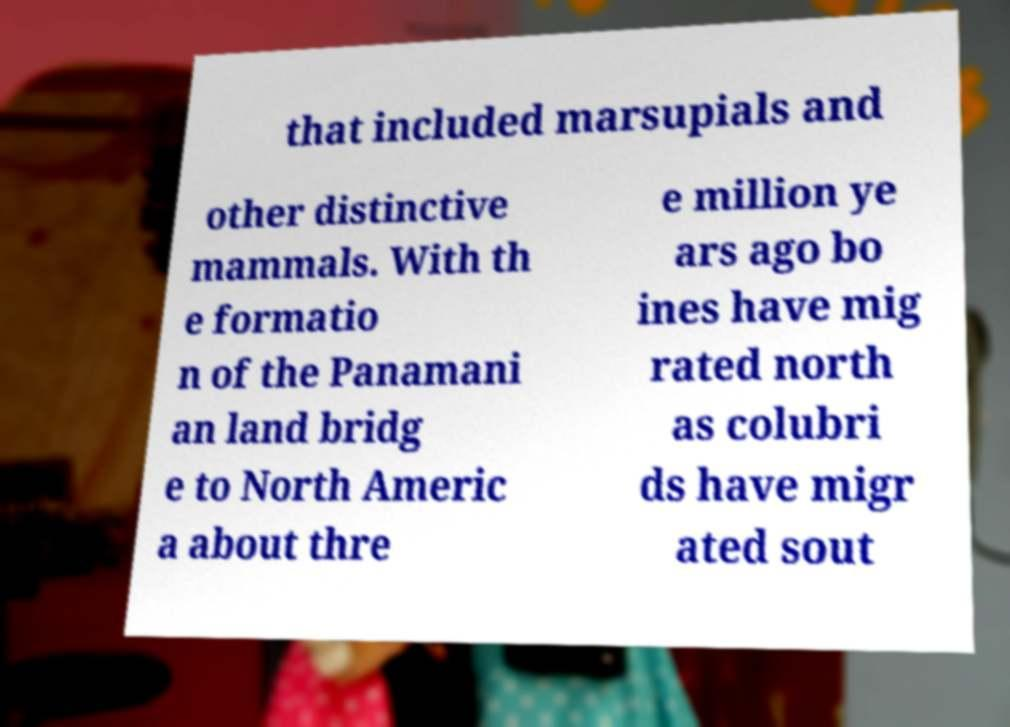Can you accurately transcribe the text from the provided image for me? that included marsupials and other distinctive mammals. With th e formatio n of the Panamani an land bridg e to North Americ a about thre e million ye ars ago bo ines have mig rated north as colubri ds have migr ated sout 